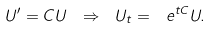<formula> <loc_0><loc_0><loc_500><loc_500>U ^ { \prime } = C U \ \Rightarrow \ U _ { t } = \ e ^ { t C } U .</formula> 